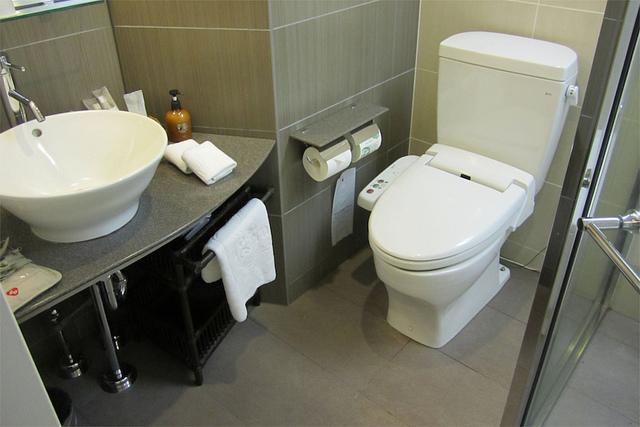What do the buttons to the right of the tissue rolls control? Please explain your reasoning. toilet. These are high end toilets that you can use the buttons to flush. 